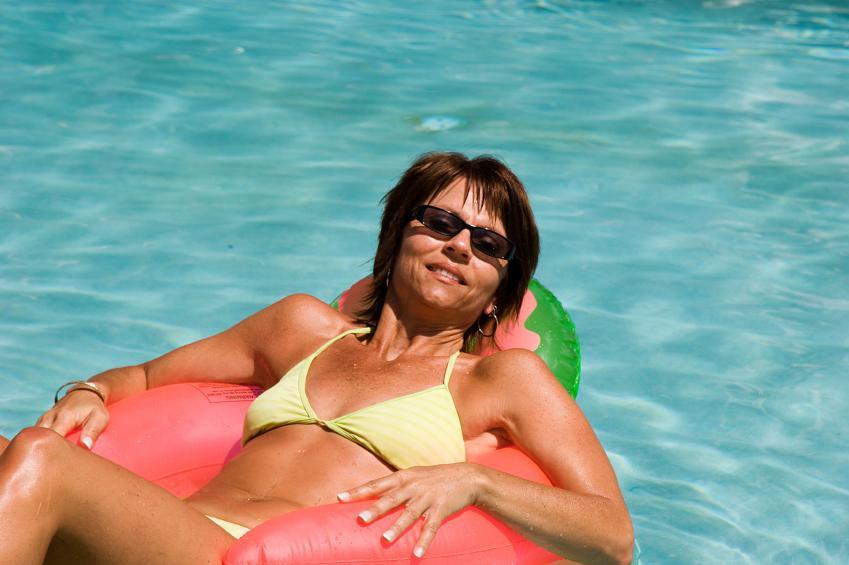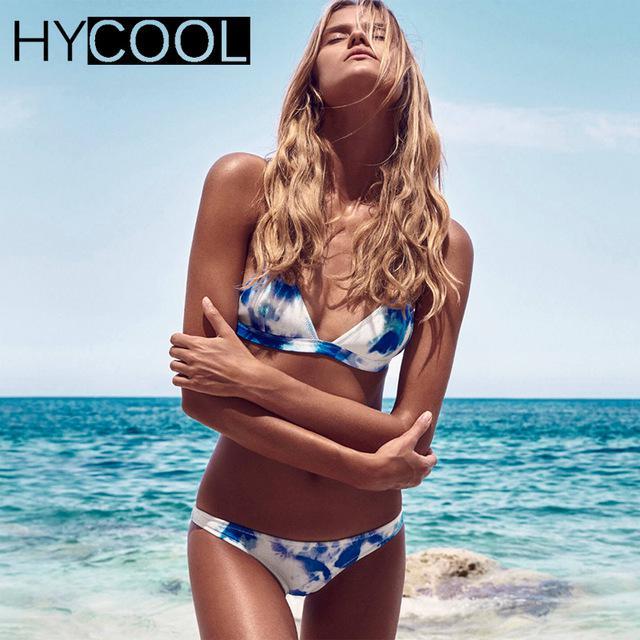The first image is the image on the left, the second image is the image on the right. Given the left and right images, does the statement "The left image contains exactly one person in the water." hold true? Answer yes or no. Yes. The first image is the image on the left, the second image is the image on the right. Analyze the images presented: Is the assertion "Four models in solid-colored bikinis are sitting on the edge of a pool dipping their toes in the water." valid? Answer yes or no. No. 